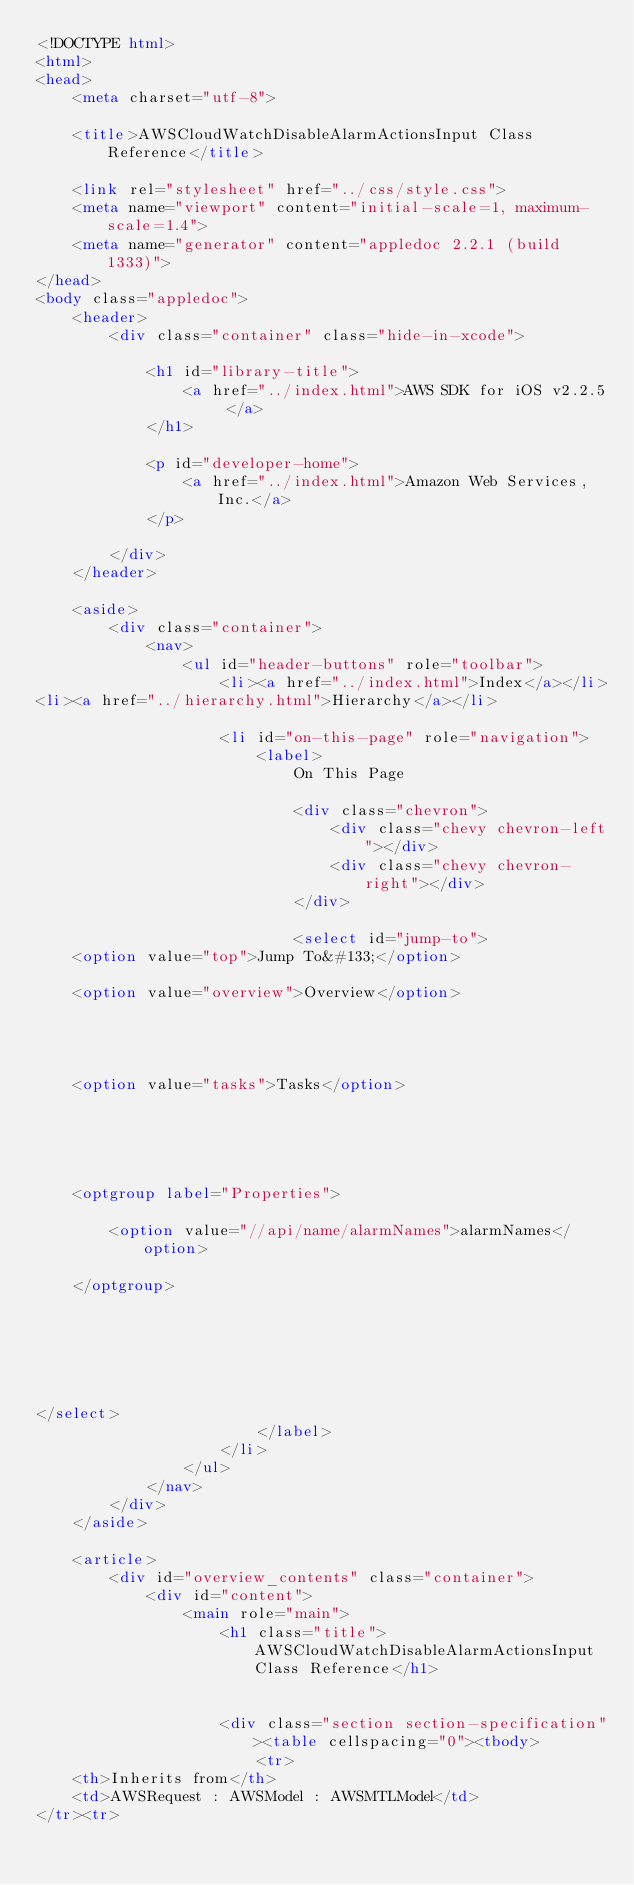<code> <loc_0><loc_0><loc_500><loc_500><_HTML_><!DOCTYPE html>
<html>
<head>
	<meta charset="utf-8">

	<title>AWSCloudWatchDisableAlarmActionsInput Class Reference</title>

	<link rel="stylesheet" href="../css/style.css">
	<meta name="viewport" content="initial-scale=1, maximum-scale=1.4">
	<meta name="generator" content="appledoc 2.2.1 (build 1333)">
</head>
<body class="appledoc">
	<header>
		<div class="container" class="hide-in-xcode">
			
			<h1 id="library-title">
				<a href="../index.html">AWS SDK for iOS v2.2.5 </a>
			</h1>

			<p id="developer-home">
				<a href="../index.html">Amazon Web Services, Inc.</a>
			</p>
			
		</div>
	</header>

	<aside>
		<div class="container">
			<nav>
				<ul id="header-buttons" role="toolbar">
					<li><a href="../index.html">Index</a></li>
<li><a href="../hierarchy.html">Hierarchy</a></li>

					<li id="on-this-page" role="navigation">
						<label>
							On This Page

							<div class="chevron">
								<div class="chevy chevron-left"></div>
								<div class="chevy chevron-right"></div>
							</div>

							<select id="jump-to">
	<option value="top">Jump To&#133;</option>
	
	<option value="overview">Overview</option>
	

	
	
	<option value="tasks">Tasks</option>
	
	

	
	
	<optgroup label="Properties">
		
		<option value="//api/name/alarmNames">alarmNames</option>
		
	</optgroup>
	

	

	
	
</select>
						</label>
					</li>
				</ul>
			</nav>
		</div>
	</aside>

	<article>
		<div id="overview_contents" class="container">
			<div id="content">
				<main role="main">
					<h1 class="title">AWSCloudWatchDisableAlarmActionsInput Class Reference</h1>

					
					<div class="section section-specification"><table cellspacing="0"><tbody>
						<tr>
	<th>Inherits from</th>
	<td>AWSRequest : AWSModel : AWSMTLModel</td>
</tr><tr></code> 